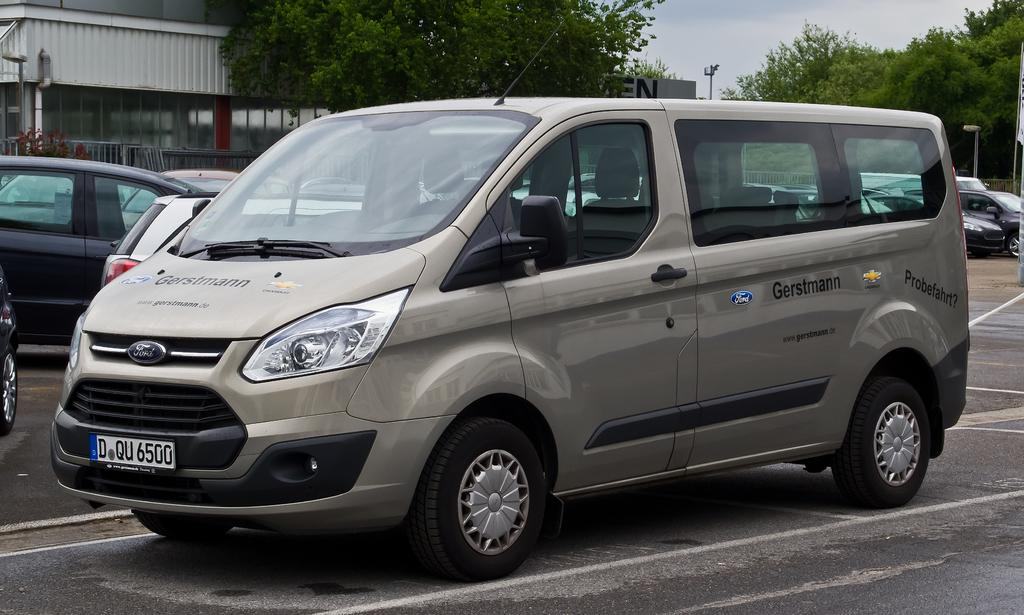What can be seen on the roads in the image? There are vehicles on the roads in the image. What type of natural elements can be seen in the background of the image? There are trees in the background of the image. What type of man-made structures can be seen in the background of the image? There are buildings in the background of the image. What type of vertical structures can be seen in the background of the image? There are poles in the background of the image. What part of the natural environment is visible in the background of the image? The sky is visible in the background of the image. Can you describe any other objects present in the background of the image? There are other objects present in the background of the image, but their specific nature cannot be determined from the provided facts. What type of doctor can be seen in the image? There is no doctor present in the image. What type of watch can be seen on the vehicles in the image? There is no watch present on the vehicles in the image. 